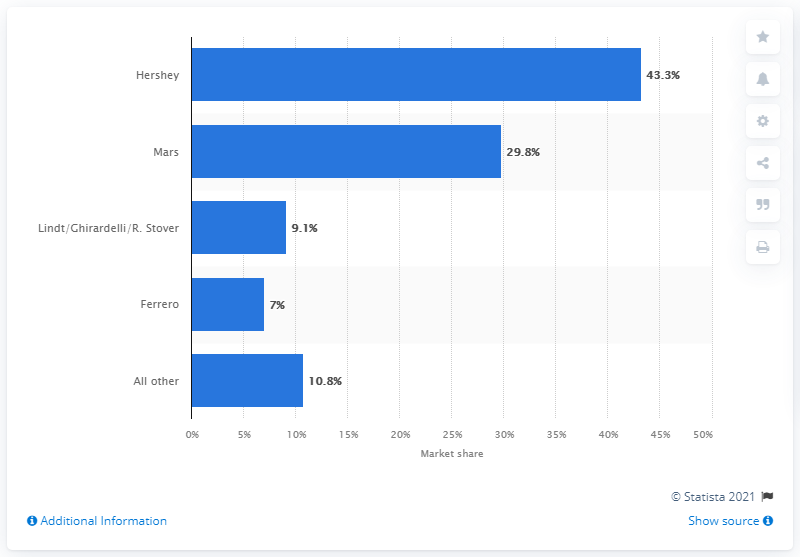Indicate a few pertinent items in this graphic. Hershey outperformed Mars in the total confectionery market, capturing 43.3% of the market share. In 2018, Hershey held a significant percentage of the chocolate market, accounting for 43.3%. 